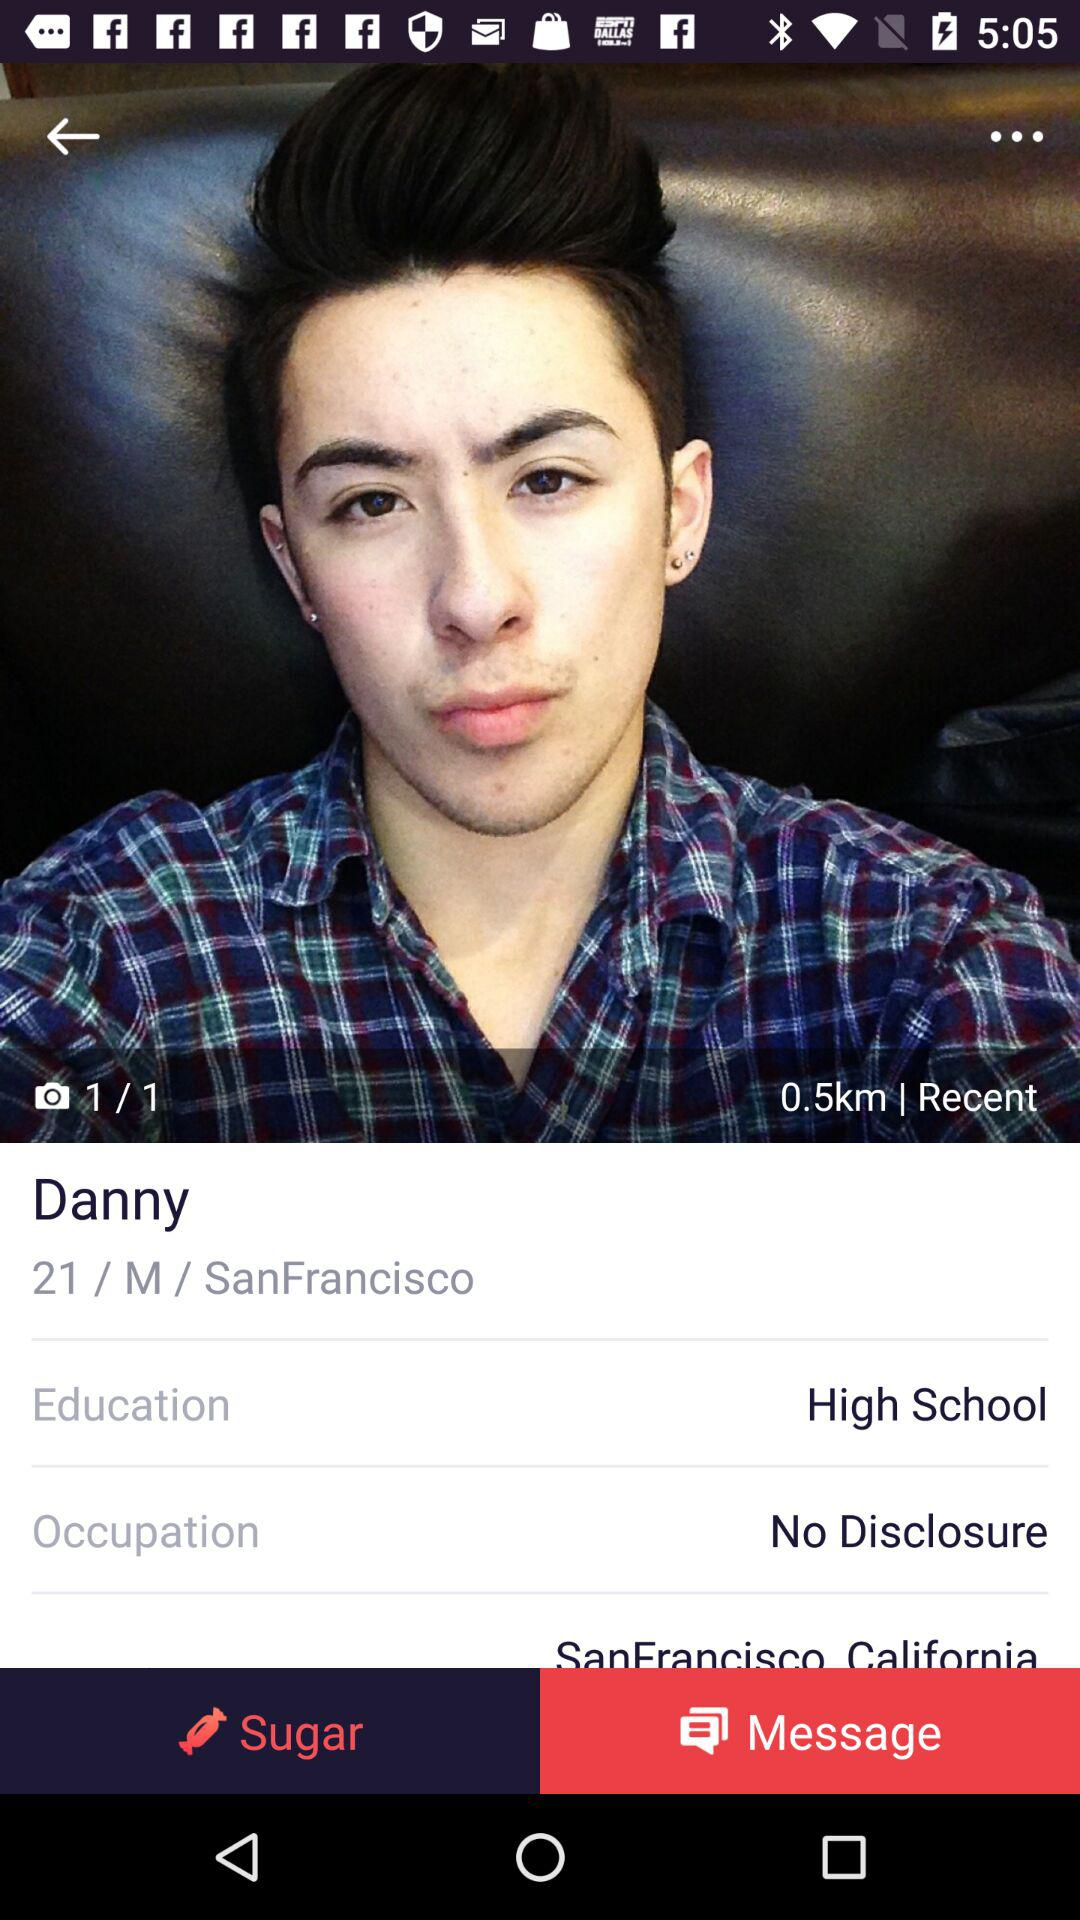What is the gender of Danny? The gender of Danny is male. 